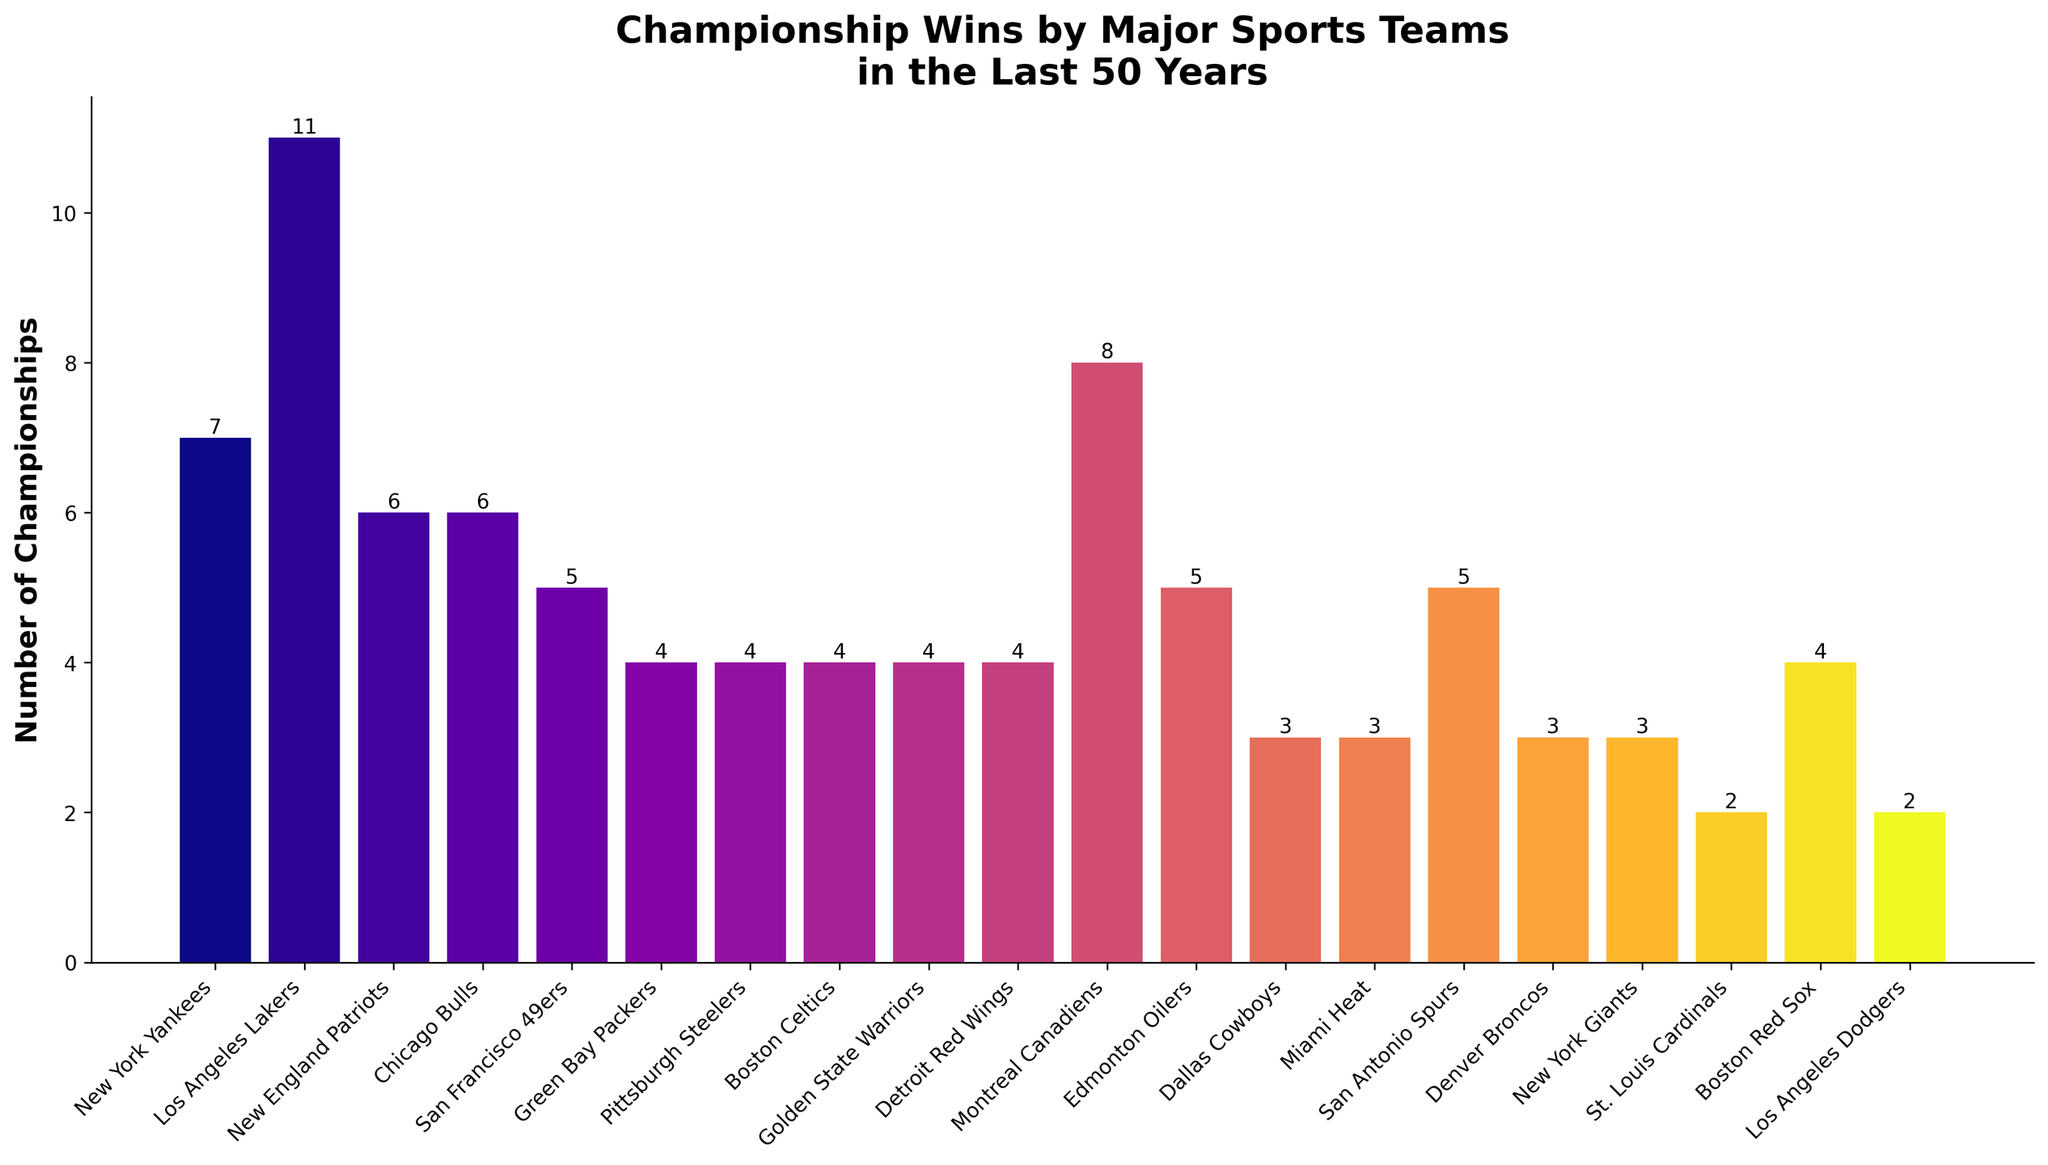What team has the most championship wins? The team with the tallest bar represents the team with the most championship wins. The Los Angeles Lakers' bar is the highest.
Answer: Los Angeles Lakers Which two teams have won 4 championships each? To identify the teams with 4 championships, look for bars with a height corresponding to 4. The teams represented by these bars are Green Bay Packers, Pittsburgh Steelers, Boston Celtics, Golden State Warriors, Detroit Red Wings, and Boston Red Sox.
Answer: Green Bay Packers, Pittsburgh Steelers, Boston Celtics, Golden State Warriors, Detroit Red Wings, Boston Red Sox How many more championships have the Los Angeles Lakers won compared to the New York Yankees? The Los Angeles Lakers have won 11 championships, and the New York Yankees have won 7. Calculate the difference: 11 - 7.
Answer: 4 Which team has won more championships: the Chicago Bulls or the San Francisco 49ers? Compare the heights of the bars for the Chicago Bulls and the San Francisco 49ers. The bar representing the Chicago Bulls is higher.
Answer: Chicago Bulls Among the Dallas Cowboys, Miami Heat, and Denver Broncos, which team has the most championships? Compare the heights of the bars for the Dallas Cowboys, Miami Heat, and Denver Broncos. The bars for all three teams are of equal height, representing 3 championships each.
Answer: All have equal What is the total number of championships won by the New England Patriots and the San Antonio Spurs? The New England Patriots have won 6 championships, and the San Antonio Spurs have won 5. Sum these numbers: 6 + 5.
Answer: 11 By how many championships does the team with the most wins differ from the team with the least wins? The Los Angeles Lakers have 11 championships, and the St. Louis Cardinals and Los Angeles Dodgers each have 2. Calculate the difference: 11 - 2.
Answer: 9 What's the average number of championships won by the New York Giants, Miami Heat, and Denver Broncos? Each team has 3 championships. Calculate the average: (3 + 3 + 3) / 3.
Answer: 3 What is the combined number of championships for the Green Bay Packers, Pittsburgh Steelers, and Boston Celtics? Each of these teams has 4 championships. Calculate the total: 4 + 4 + 4.
Answer: 12 